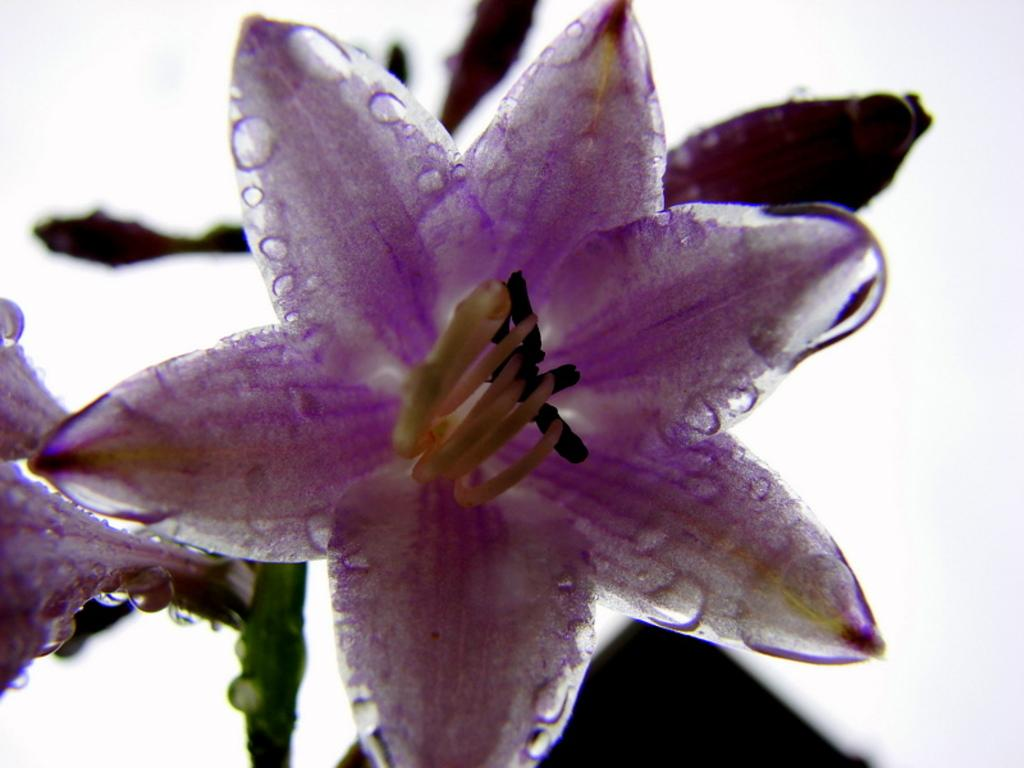What is the main subject of the image? There is a flower in the image. What type of ornament is hanging from the moon in the image? There is no moon or ornament present in the image; it only features a flower. 